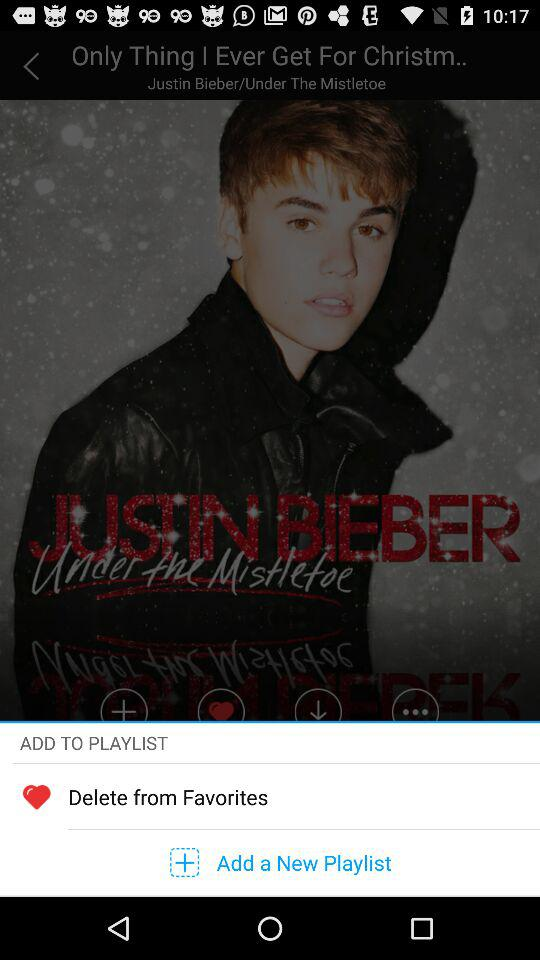What is the title of the song? The title is "Only Thing I Ever Get For Christm..". 